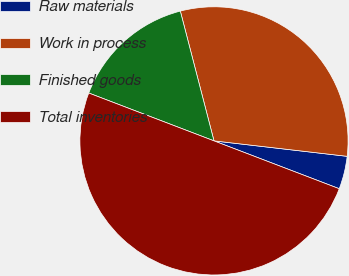Convert chart. <chart><loc_0><loc_0><loc_500><loc_500><pie_chart><fcel>Raw materials<fcel>Work in process<fcel>Finished goods<fcel>Total inventories<nl><fcel>3.97%<fcel>30.88%<fcel>15.15%<fcel>50.0%<nl></chart> 